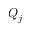<formula> <loc_0><loc_0><loc_500><loc_500>Q _ { j }</formula> 